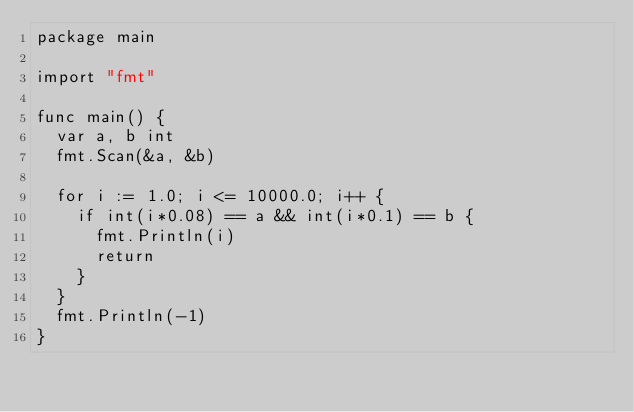Convert code to text. <code><loc_0><loc_0><loc_500><loc_500><_Go_>package main

import "fmt"

func main() {
	var a, b int
	fmt.Scan(&a, &b)

	for i := 1.0; i <= 10000.0; i++ {
		if int(i*0.08) == a && int(i*0.1) == b {
			fmt.Println(i)
			return
		}
	}
	fmt.Println(-1)
}
</code> 